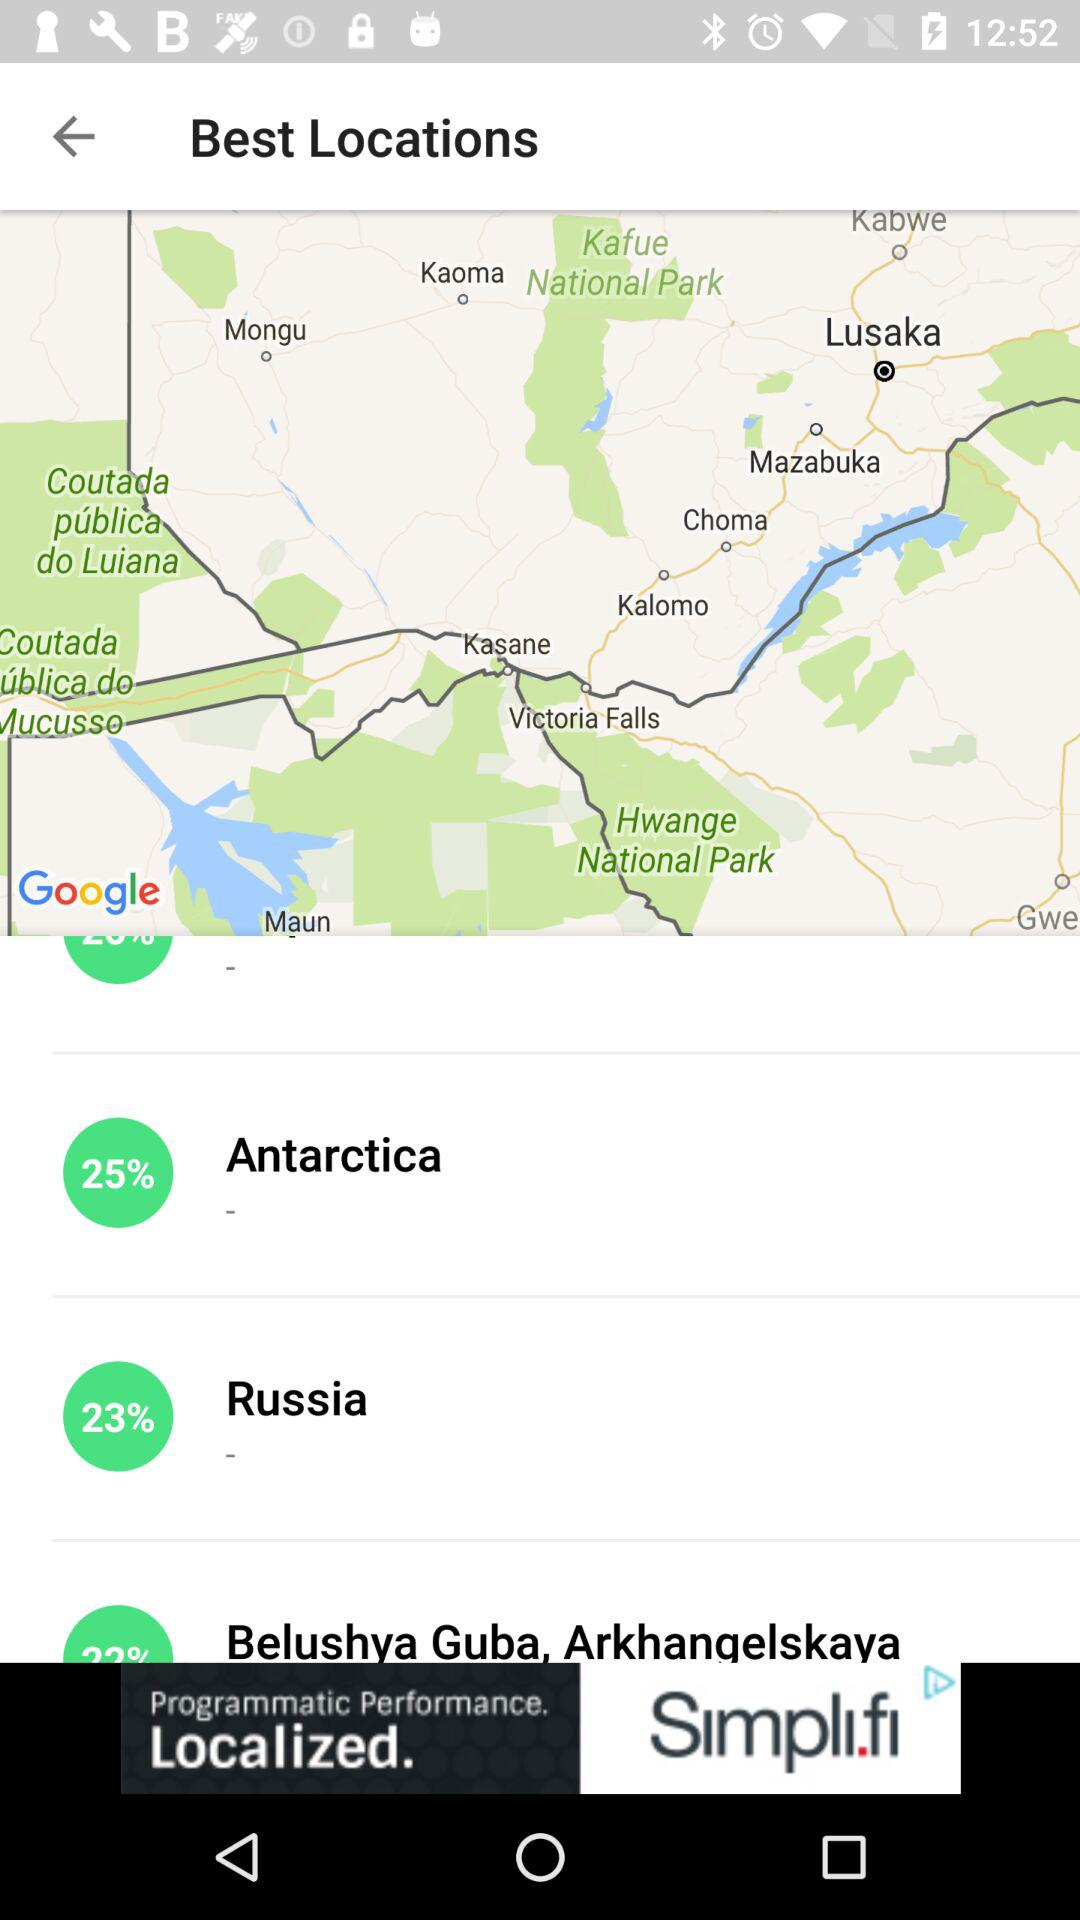What is the KP Index? The KP Index is 3.33. 